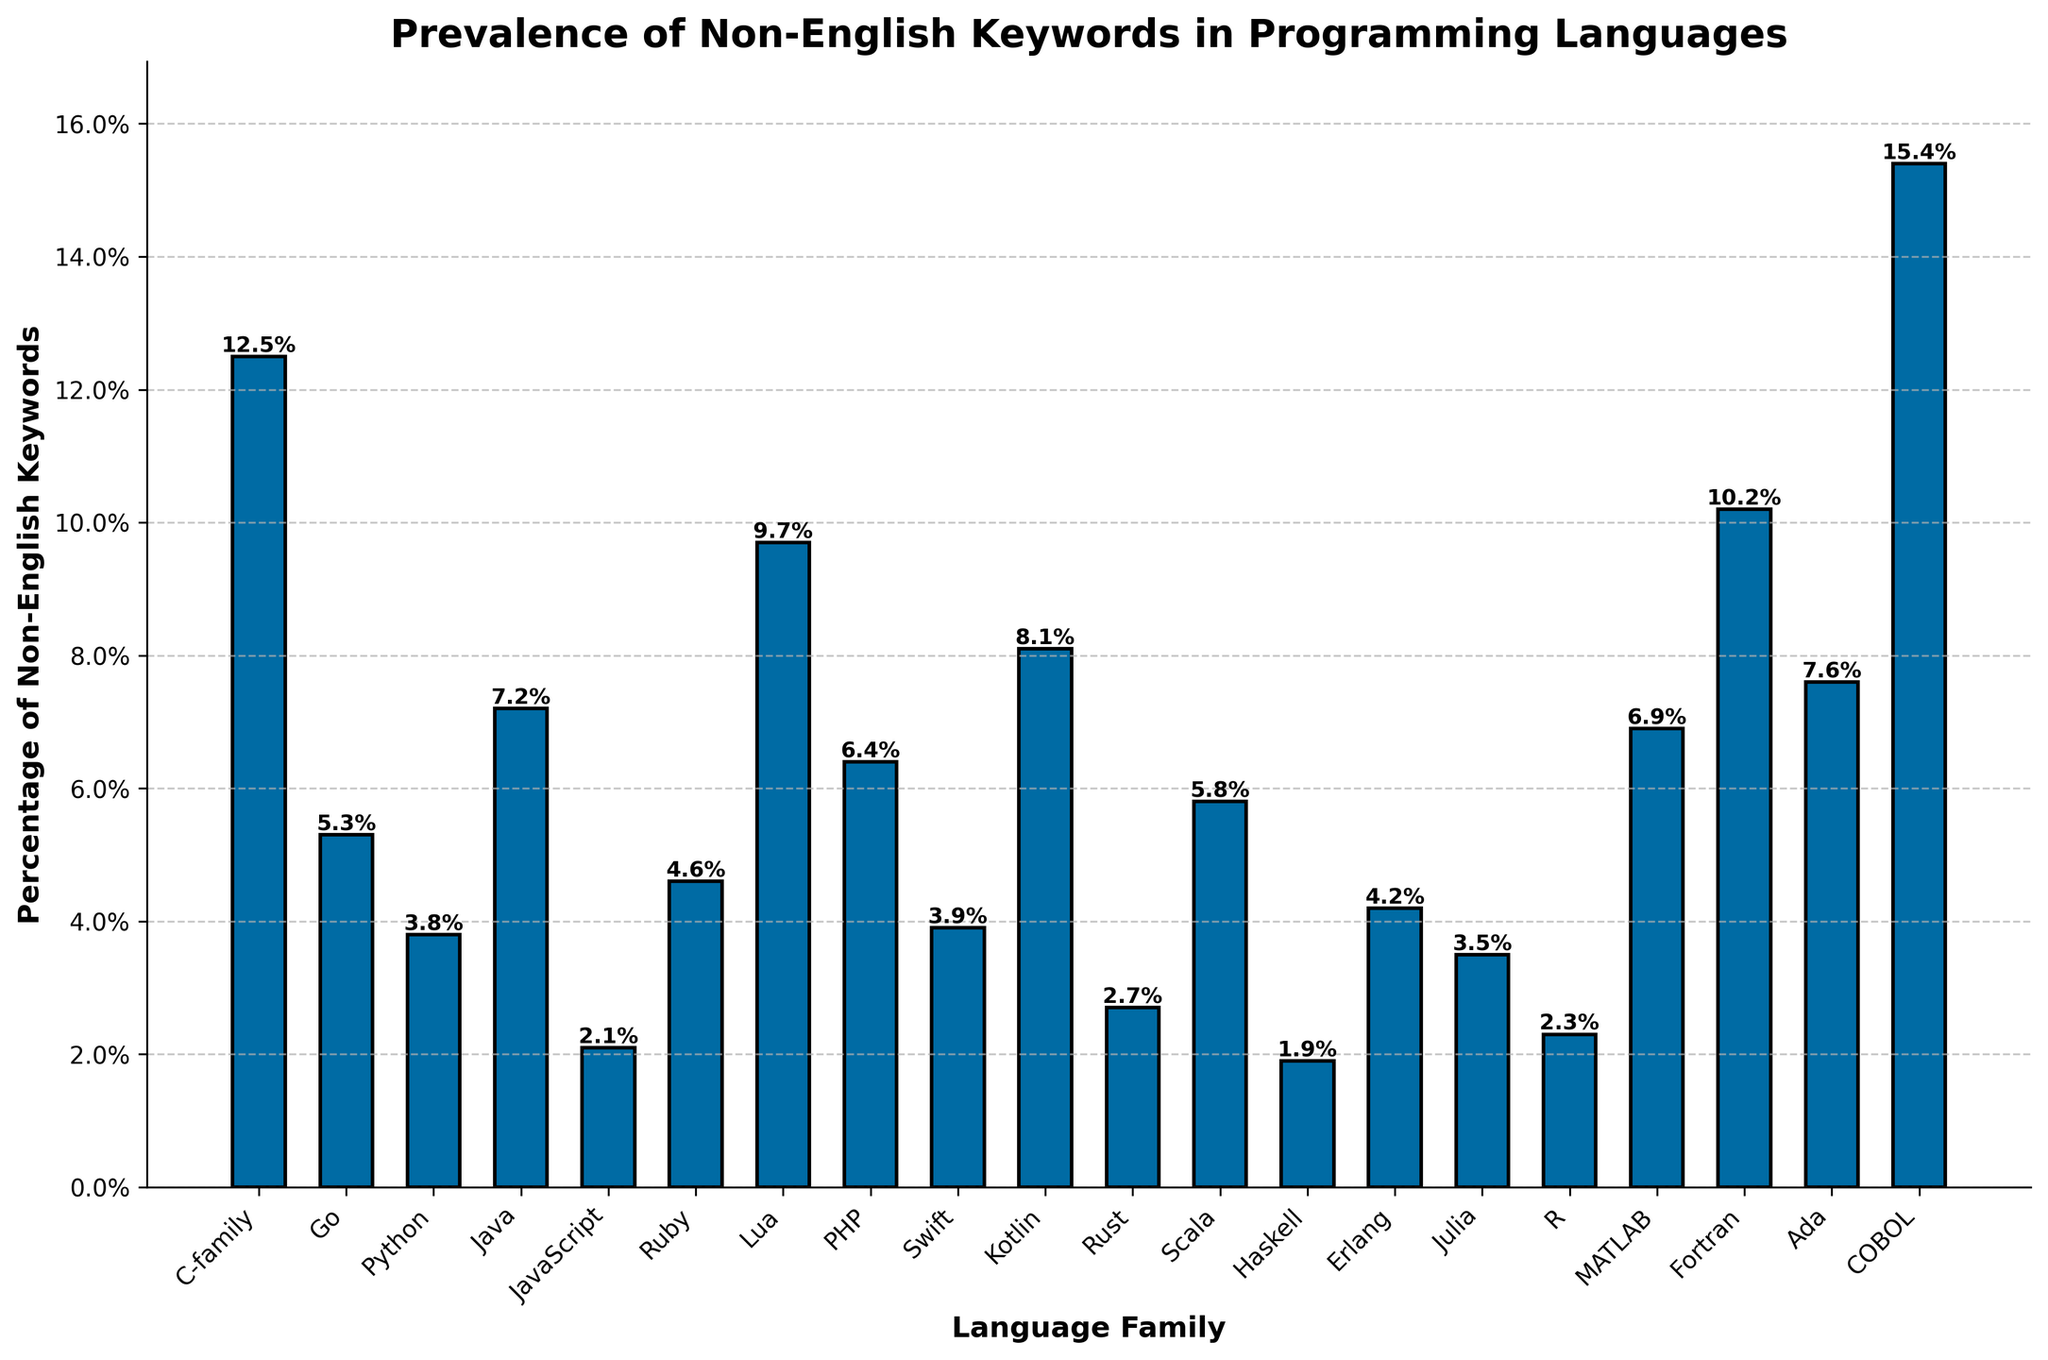Which language family has the highest percentage of non-English keywords? The highest bar represents COBOL with 15.4% of non-English keywords.
Answer: COBOL Which language family has the lowest percentage of non-English keywords? The lowest bar represents Haskell with 1.9% of non-English keywords.
Answer: Haskell Compare the percentage of non-English keywords between Fortran and Ada. Which one is higher and by how much? Fortran has a percentage of 10.2% while Ada has 7.6%. Subtracting the lower percentage from the higher percentage, 10.2% - 7.6% = 2.6%.
Answer: Fortran by 2.6% What is the average percentage of non-English keywords for the C-family, Go, and Python? Add the percentages of C-family (12.5%), Go (5.3%), and Python (3.8%) and then divide by 3. (12.5 + 5.3 + 3.8) / 3 = 21.6 / 3 = 7.2%
Answer: 7.2% What is the difference in percentage of non-English keywords between the language families with the highest and lowest values? COBOL has the highest percentage of 15.4%, and Haskell has the lowest at 1.9%. The difference is 15.4% - 1.9% = 13.5%.
Answer: 13.5% Which three languages have the closest percentages of non-English keywords and what are those percentages? JavaScript (2.1%), R (2.3%), and Rust (2.7%) have close percentages. Check visually and find the smallest differences between their values.
Answer: JavaScript, R, Rust: 2.1%, 2.3%, 2.7% What is the combined percentage of non-English keywords for Java, Kotlin, and Swift? Add the percentages: Java (7.2%), Kotlin (8.1%), Swift (3.9%). 7.2 + 8.1 + 3.9 = 19.2%.
Answer: 19.2% How many language families have a percentage of non-English keywords above 10%? Visually count the bars that extend above the 10% mark. COBOL, Fortran, C-family.
Answer: 3 Which language family has a slightly higher percentage of non-English keywords: Erlang or Ruby? Compare the heights of the bars for Erlang (4.2%) and Ruby (4.6%). Ruby's bar is slightly higher.
Answer: Ruby Is the percentage of non-English keywords in Scala higher or lower than in PHP? By how much? Scala has 5.8% and PHP has 6.4%. Subtract Scala's percentage from PHP's percentage: 6.4% - 5.8% = 0.6%.
Answer: Lower by 0.6% 